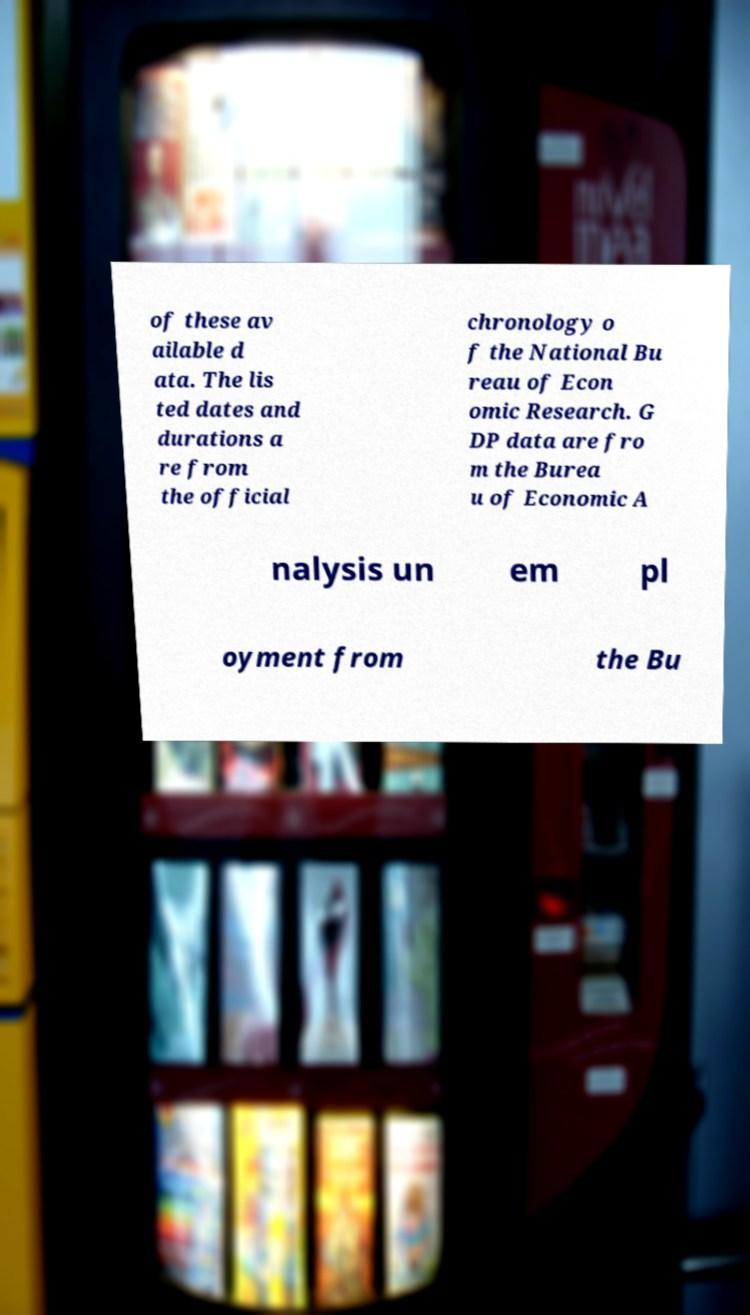There's text embedded in this image that I need extracted. Can you transcribe it verbatim? of these av ailable d ata. The lis ted dates and durations a re from the official chronology o f the National Bu reau of Econ omic Research. G DP data are fro m the Burea u of Economic A nalysis un em pl oyment from the Bu 